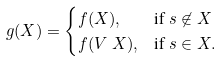Convert formula to latex. <formula><loc_0><loc_0><loc_500><loc_500>g ( X ) & = \begin{cases} f ( X ) , & \text {if } s \not \in X \\ f ( V \ X ) , & \text {if } s \in X . \end{cases}</formula> 